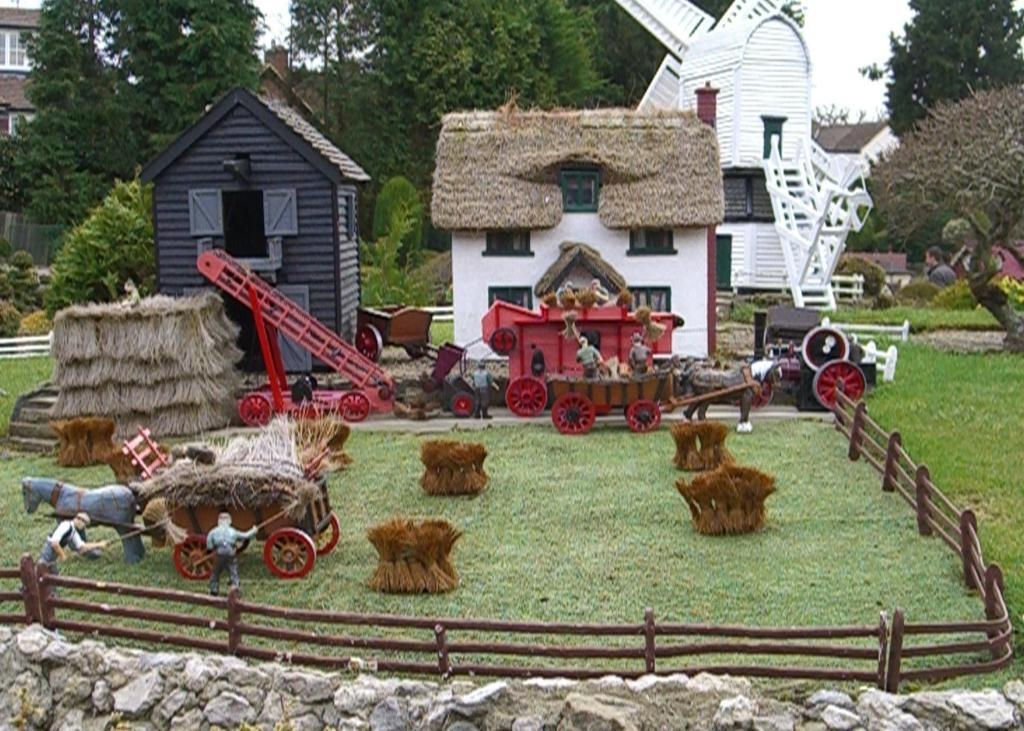What type of toys can be seen in the image? There are toy vehicles and a toy horse in the image. What kind of structures are present in the image? There are buildings in the image. What type of barrier can be seen in the image? There is fencing in the image. What is the ground made of in the image? There is dry grass in the image. What type of vegetation is present in the image? There are trees in the image. What architectural feature can be seen on the buildings in the image? There are windows in the image. What is the color of the sky in the image? The sky is white in color. What type of memory is stored in the toy vehicles in the image? There is no indication in the image that the toy vehicles have any memory storage capabilities. 